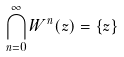<formula> <loc_0><loc_0><loc_500><loc_500>\bigcap _ { n = 0 } ^ { \infty } W ^ { n } ( z ) = \{ z \}</formula> 